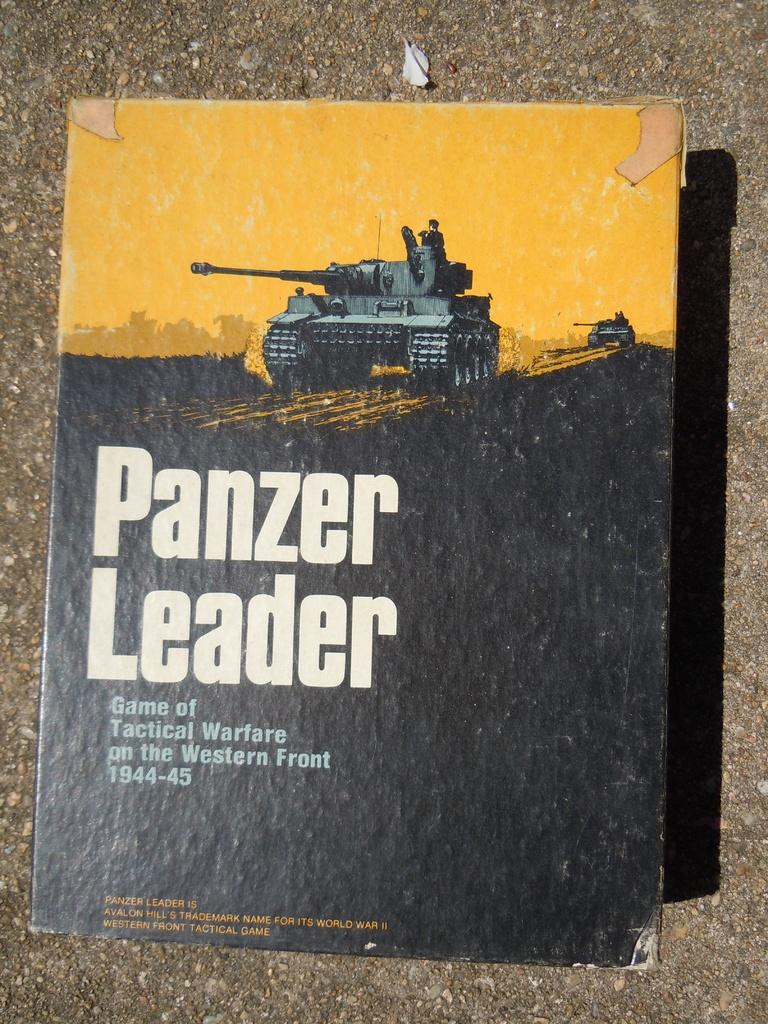What is the main subject of the image? The image shows the cover page of a book. What type of vehicles are depicted on the book cover? There are military vehicles depicted on the book cover. Is there any text on the book cover? Yes, there is text written on the book cover. What is the color of the surface the book cover is placed on? The book cover is on a brown color surface. How does the fireman put out the fire on the book cover? There is no fire or fireman depicted on the book cover; it features military vehicles and text. 